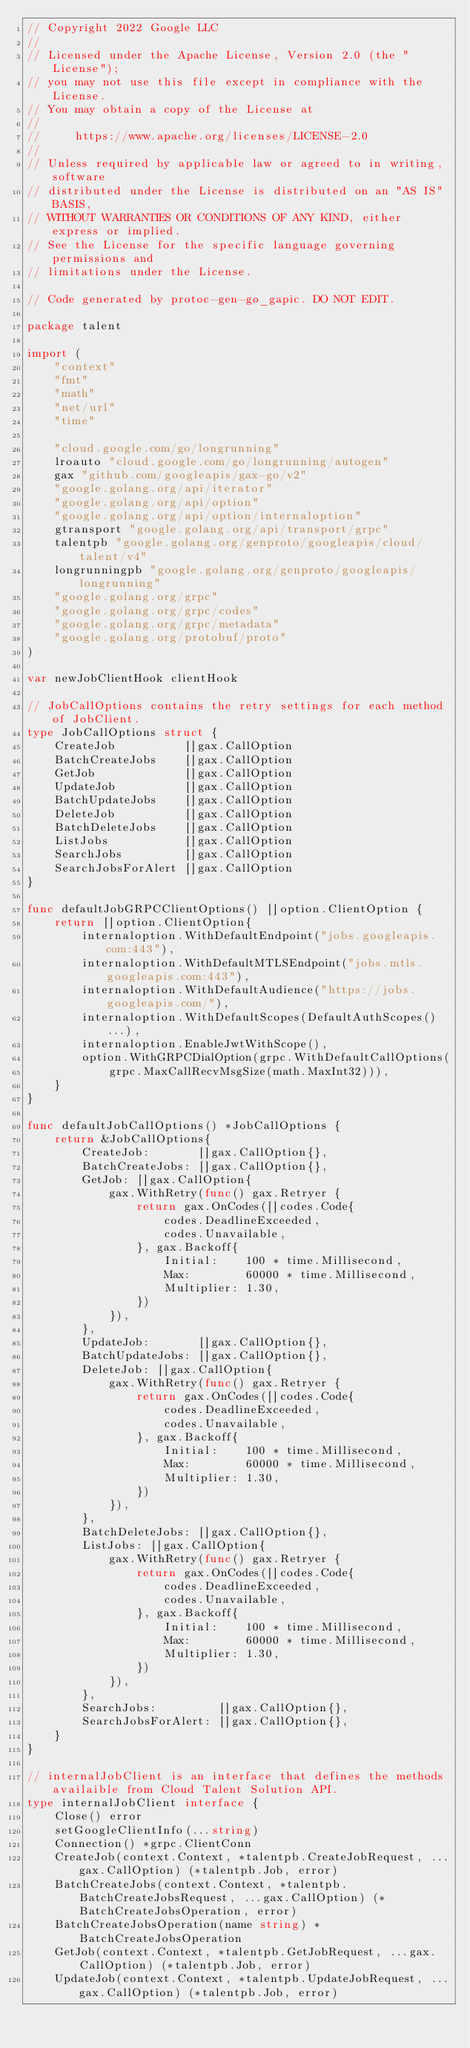Convert code to text. <code><loc_0><loc_0><loc_500><loc_500><_Go_>// Copyright 2022 Google LLC
//
// Licensed under the Apache License, Version 2.0 (the "License");
// you may not use this file except in compliance with the License.
// You may obtain a copy of the License at
//
//     https://www.apache.org/licenses/LICENSE-2.0
//
// Unless required by applicable law or agreed to in writing, software
// distributed under the License is distributed on an "AS IS" BASIS,
// WITHOUT WARRANTIES OR CONDITIONS OF ANY KIND, either express or implied.
// See the License for the specific language governing permissions and
// limitations under the License.

// Code generated by protoc-gen-go_gapic. DO NOT EDIT.

package talent

import (
	"context"
	"fmt"
	"math"
	"net/url"
	"time"

	"cloud.google.com/go/longrunning"
	lroauto "cloud.google.com/go/longrunning/autogen"
	gax "github.com/googleapis/gax-go/v2"
	"google.golang.org/api/iterator"
	"google.golang.org/api/option"
	"google.golang.org/api/option/internaloption"
	gtransport "google.golang.org/api/transport/grpc"
	talentpb "google.golang.org/genproto/googleapis/cloud/talent/v4"
	longrunningpb "google.golang.org/genproto/googleapis/longrunning"
	"google.golang.org/grpc"
	"google.golang.org/grpc/codes"
	"google.golang.org/grpc/metadata"
	"google.golang.org/protobuf/proto"
)

var newJobClientHook clientHook

// JobCallOptions contains the retry settings for each method of JobClient.
type JobCallOptions struct {
	CreateJob          []gax.CallOption
	BatchCreateJobs    []gax.CallOption
	GetJob             []gax.CallOption
	UpdateJob          []gax.CallOption
	BatchUpdateJobs    []gax.CallOption
	DeleteJob          []gax.CallOption
	BatchDeleteJobs    []gax.CallOption
	ListJobs           []gax.CallOption
	SearchJobs         []gax.CallOption
	SearchJobsForAlert []gax.CallOption
}

func defaultJobGRPCClientOptions() []option.ClientOption {
	return []option.ClientOption{
		internaloption.WithDefaultEndpoint("jobs.googleapis.com:443"),
		internaloption.WithDefaultMTLSEndpoint("jobs.mtls.googleapis.com:443"),
		internaloption.WithDefaultAudience("https://jobs.googleapis.com/"),
		internaloption.WithDefaultScopes(DefaultAuthScopes()...),
		internaloption.EnableJwtWithScope(),
		option.WithGRPCDialOption(grpc.WithDefaultCallOptions(
			grpc.MaxCallRecvMsgSize(math.MaxInt32))),
	}
}

func defaultJobCallOptions() *JobCallOptions {
	return &JobCallOptions{
		CreateJob:       []gax.CallOption{},
		BatchCreateJobs: []gax.CallOption{},
		GetJob: []gax.CallOption{
			gax.WithRetry(func() gax.Retryer {
				return gax.OnCodes([]codes.Code{
					codes.DeadlineExceeded,
					codes.Unavailable,
				}, gax.Backoff{
					Initial:    100 * time.Millisecond,
					Max:        60000 * time.Millisecond,
					Multiplier: 1.30,
				})
			}),
		},
		UpdateJob:       []gax.CallOption{},
		BatchUpdateJobs: []gax.CallOption{},
		DeleteJob: []gax.CallOption{
			gax.WithRetry(func() gax.Retryer {
				return gax.OnCodes([]codes.Code{
					codes.DeadlineExceeded,
					codes.Unavailable,
				}, gax.Backoff{
					Initial:    100 * time.Millisecond,
					Max:        60000 * time.Millisecond,
					Multiplier: 1.30,
				})
			}),
		},
		BatchDeleteJobs: []gax.CallOption{},
		ListJobs: []gax.CallOption{
			gax.WithRetry(func() gax.Retryer {
				return gax.OnCodes([]codes.Code{
					codes.DeadlineExceeded,
					codes.Unavailable,
				}, gax.Backoff{
					Initial:    100 * time.Millisecond,
					Max:        60000 * time.Millisecond,
					Multiplier: 1.30,
				})
			}),
		},
		SearchJobs:         []gax.CallOption{},
		SearchJobsForAlert: []gax.CallOption{},
	}
}

// internalJobClient is an interface that defines the methods availaible from Cloud Talent Solution API.
type internalJobClient interface {
	Close() error
	setGoogleClientInfo(...string)
	Connection() *grpc.ClientConn
	CreateJob(context.Context, *talentpb.CreateJobRequest, ...gax.CallOption) (*talentpb.Job, error)
	BatchCreateJobs(context.Context, *talentpb.BatchCreateJobsRequest, ...gax.CallOption) (*BatchCreateJobsOperation, error)
	BatchCreateJobsOperation(name string) *BatchCreateJobsOperation
	GetJob(context.Context, *talentpb.GetJobRequest, ...gax.CallOption) (*talentpb.Job, error)
	UpdateJob(context.Context, *talentpb.UpdateJobRequest, ...gax.CallOption) (*talentpb.Job, error)</code> 